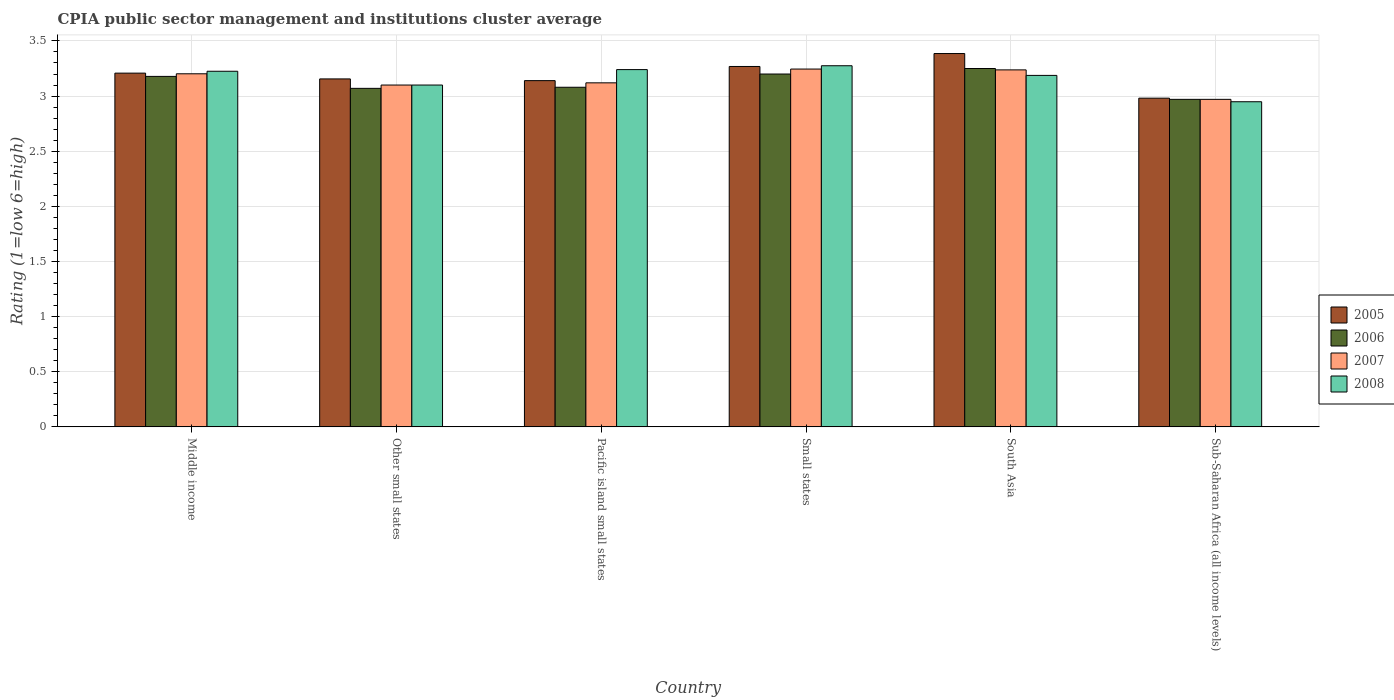Are the number of bars on each tick of the X-axis equal?
Offer a very short reply. Yes. What is the label of the 2nd group of bars from the left?
Provide a short and direct response. Other small states. What is the CPIA rating in 2008 in Other small states?
Offer a terse response. 3.1. Across all countries, what is the maximum CPIA rating in 2007?
Give a very brief answer. 3.25. Across all countries, what is the minimum CPIA rating in 2008?
Give a very brief answer. 2.95. In which country was the CPIA rating in 2008 maximum?
Offer a very short reply. Small states. In which country was the CPIA rating in 2007 minimum?
Your answer should be very brief. Sub-Saharan Africa (all income levels). What is the total CPIA rating in 2007 in the graph?
Provide a short and direct response. 18.87. What is the difference between the CPIA rating in 2008 in Other small states and that in Sub-Saharan Africa (all income levels)?
Provide a short and direct response. 0.15. What is the difference between the CPIA rating in 2007 in South Asia and the CPIA rating in 2008 in Small states?
Provide a short and direct response. -0.04. What is the average CPIA rating in 2008 per country?
Ensure brevity in your answer.  3.16. What is the difference between the CPIA rating of/in 2005 and CPIA rating of/in 2007 in Other small states?
Make the answer very short. 0.06. What is the ratio of the CPIA rating in 2008 in Middle income to that in Other small states?
Make the answer very short. 1.04. What is the difference between the highest and the second highest CPIA rating in 2007?
Offer a very short reply. -0.01. What is the difference between the highest and the lowest CPIA rating in 2005?
Your response must be concise. 0.4. In how many countries, is the CPIA rating in 2006 greater than the average CPIA rating in 2006 taken over all countries?
Give a very brief answer. 3. Is the sum of the CPIA rating in 2006 in Middle income and Pacific island small states greater than the maximum CPIA rating in 2007 across all countries?
Offer a very short reply. Yes. Is it the case that in every country, the sum of the CPIA rating in 2008 and CPIA rating in 2005 is greater than the sum of CPIA rating in 2006 and CPIA rating in 2007?
Make the answer very short. No. What does the 3rd bar from the left in South Asia represents?
Your answer should be very brief. 2007. What does the 2nd bar from the right in Middle income represents?
Your answer should be very brief. 2007. Are all the bars in the graph horizontal?
Give a very brief answer. No. How many countries are there in the graph?
Ensure brevity in your answer.  6. What is the difference between two consecutive major ticks on the Y-axis?
Offer a very short reply. 0.5. Does the graph contain any zero values?
Ensure brevity in your answer.  No. Does the graph contain grids?
Your answer should be very brief. Yes. Where does the legend appear in the graph?
Offer a very short reply. Center right. How many legend labels are there?
Your answer should be compact. 4. What is the title of the graph?
Offer a very short reply. CPIA public sector management and institutions cluster average. Does "1975" appear as one of the legend labels in the graph?
Offer a terse response. No. What is the label or title of the X-axis?
Offer a terse response. Country. What is the Rating (1=low 6=high) of 2005 in Middle income?
Give a very brief answer. 3.21. What is the Rating (1=low 6=high) in 2006 in Middle income?
Your answer should be very brief. 3.18. What is the Rating (1=low 6=high) in 2007 in Middle income?
Make the answer very short. 3.2. What is the Rating (1=low 6=high) of 2008 in Middle income?
Provide a succinct answer. 3.23. What is the Rating (1=low 6=high) of 2005 in Other small states?
Ensure brevity in your answer.  3.16. What is the Rating (1=low 6=high) of 2006 in Other small states?
Provide a succinct answer. 3.07. What is the Rating (1=low 6=high) in 2008 in Other small states?
Keep it short and to the point. 3.1. What is the Rating (1=low 6=high) of 2005 in Pacific island small states?
Make the answer very short. 3.14. What is the Rating (1=low 6=high) of 2006 in Pacific island small states?
Your response must be concise. 3.08. What is the Rating (1=low 6=high) of 2007 in Pacific island small states?
Your answer should be very brief. 3.12. What is the Rating (1=low 6=high) in 2008 in Pacific island small states?
Your response must be concise. 3.24. What is the Rating (1=low 6=high) of 2005 in Small states?
Offer a terse response. 3.27. What is the Rating (1=low 6=high) in 2007 in Small states?
Ensure brevity in your answer.  3.25. What is the Rating (1=low 6=high) of 2008 in Small states?
Your response must be concise. 3.27. What is the Rating (1=low 6=high) in 2005 in South Asia?
Keep it short and to the point. 3.39. What is the Rating (1=low 6=high) in 2006 in South Asia?
Provide a succinct answer. 3.25. What is the Rating (1=low 6=high) in 2007 in South Asia?
Your response must be concise. 3.24. What is the Rating (1=low 6=high) in 2008 in South Asia?
Provide a short and direct response. 3.19. What is the Rating (1=low 6=high) in 2005 in Sub-Saharan Africa (all income levels)?
Ensure brevity in your answer.  2.98. What is the Rating (1=low 6=high) in 2006 in Sub-Saharan Africa (all income levels)?
Ensure brevity in your answer.  2.97. What is the Rating (1=low 6=high) in 2007 in Sub-Saharan Africa (all income levels)?
Make the answer very short. 2.97. What is the Rating (1=low 6=high) in 2008 in Sub-Saharan Africa (all income levels)?
Ensure brevity in your answer.  2.95. Across all countries, what is the maximum Rating (1=low 6=high) of 2005?
Keep it short and to the point. 3.39. Across all countries, what is the maximum Rating (1=low 6=high) of 2006?
Provide a short and direct response. 3.25. Across all countries, what is the maximum Rating (1=low 6=high) in 2007?
Your answer should be very brief. 3.25. Across all countries, what is the maximum Rating (1=low 6=high) in 2008?
Provide a succinct answer. 3.27. Across all countries, what is the minimum Rating (1=low 6=high) of 2005?
Provide a succinct answer. 2.98. Across all countries, what is the minimum Rating (1=low 6=high) of 2006?
Your answer should be compact. 2.97. Across all countries, what is the minimum Rating (1=low 6=high) of 2007?
Your response must be concise. 2.97. Across all countries, what is the minimum Rating (1=low 6=high) in 2008?
Offer a very short reply. 2.95. What is the total Rating (1=low 6=high) of 2005 in the graph?
Offer a terse response. 19.14. What is the total Rating (1=low 6=high) in 2006 in the graph?
Your answer should be very brief. 18.75. What is the total Rating (1=low 6=high) in 2007 in the graph?
Make the answer very short. 18.87. What is the total Rating (1=low 6=high) in 2008 in the graph?
Your answer should be very brief. 18.98. What is the difference between the Rating (1=low 6=high) of 2005 in Middle income and that in Other small states?
Provide a short and direct response. 0.05. What is the difference between the Rating (1=low 6=high) in 2006 in Middle income and that in Other small states?
Make the answer very short. 0.11. What is the difference between the Rating (1=low 6=high) in 2007 in Middle income and that in Other small states?
Your answer should be very brief. 0.1. What is the difference between the Rating (1=low 6=high) in 2008 in Middle income and that in Other small states?
Keep it short and to the point. 0.12. What is the difference between the Rating (1=low 6=high) of 2005 in Middle income and that in Pacific island small states?
Your answer should be very brief. 0.07. What is the difference between the Rating (1=low 6=high) of 2006 in Middle income and that in Pacific island small states?
Make the answer very short. 0.1. What is the difference between the Rating (1=low 6=high) of 2007 in Middle income and that in Pacific island small states?
Provide a succinct answer. 0.08. What is the difference between the Rating (1=low 6=high) in 2008 in Middle income and that in Pacific island small states?
Give a very brief answer. -0.01. What is the difference between the Rating (1=low 6=high) in 2005 in Middle income and that in Small states?
Ensure brevity in your answer.  -0.06. What is the difference between the Rating (1=low 6=high) of 2006 in Middle income and that in Small states?
Keep it short and to the point. -0.02. What is the difference between the Rating (1=low 6=high) of 2007 in Middle income and that in Small states?
Give a very brief answer. -0.04. What is the difference between the Rating (1=low 6=high) in 2008 in Middle income and that in Small states?
Offer a very short reply. -0.05. What is the difference between the Rating (1=low 6=high) of 2005 in Middle income and that in South Asia?
Your response must be concise. -0.18. What is the difference between the Rating (1=low 6=high) of 2006 in Middle income and that in South Asia?
Your answer should be very brief. -0.07. What is the difference between the Rating (1=low 6=high) in 2007 in Middle income and that in South Asia?
Your answer should be very brief. -0.04. What is the difference between the Rating (1=low 6=high) of 2008 in Middle income and that in South Asia?
Make the answer very short. 0.04. What is the difference between the Rating (1=low 6=high) of 2005 in Middle income and that in Sub-Saharan Africa (all income levels)?
Your response must be concise. 0.23. What is the difference between the Rating (1=low 6=high) in 2006 in Middle income and that in Sub-Saharan Africa (all income levels)?
Give a very brief answer. 0.21. What is the difference between the Rating (1=low 6=high) in 2007 in Middle income and that in Sub-Saharan Africa (all income levels)?
Your response must be concise. 0.23. What is the difference between the Rating (1=low 6=high) of 2008 in Middle income and that in Sub-Saharan Africa (all income levels)?
Your answer should be compact. 0.28. What is the difference between the Rating (1=low 6=high) in 2005 in Other small states and that in Pacific island small states?
Your answer should be compact. 0.02. What is the difference between the Rating (1=low 6=high) in 2006 in Other small states and that in Pacific island small states?
Keep it short and to the point. -0.01. What is the difference between the Rating (1=low 6=high) in 2007 in Other small states and that in Pacific island small states?
Your response must be concise. -0.02. What is the difference between the Rating (1=low 6=high) of 2008 in Other small states and that in Pacific island small states?
Make the answer very short. -0.14. What is the difference between the Rating (1=low 6=high) of 2005 in Other small states and that in Small states?
Keep it short and to the point. -0.11. What is the difference between the Rating (1=low 6=high) of 2006 in Other small states and that in Small states?
Ensure brevity in your answer.  -0.13. What is the difference between the Rating (1=low 6=high) in 2007 in Other small states and that in Small states?
Provide a succinct answer. -0.14. What is the difference between the Rating (1=low 6=high) in 2008 in Other small states and that in Small states?
Provide a short and direct response. -0.17. What is the difference between the Rating (1=low 6=high) of 2005 in Other small states and that in South Asia?
Provide a succinct answer. -0.23. What is the difference between the Rating (1=low 6=high) of 2006 in Other small states and that in South Asia?
Your answer should be compact. -0.18. What is the difference between the Rating (1=low 6=high) in 2007 in Other small states and that in South Asia?
Your response must be concise. -0.14. What is the difference between the Rating (1=low 6=high) of 2008 in Other small states and that in South Asia?
Your response must be concise. -0.09. What is the difference between the Rating (1=low 6=high) of 2005 in Other small states and that in Sub-Saharan Africa (all income levels)?
Give a very brief answer. 0.17. What is the difference between the Rating (1=low 6=high) in 2006 in Other small states and that in Sub-Saharan Africa (all income levels)?
Your answer should be very brief. 0.1. What is the difference between the Rating (1=low 6=high) in 2007 in Other small states and that in Sub-Saharan Africa (all income levels)?
Make the answer very short. 0.13. What is the difference between the Rating (1=low 6=high) of 2008 in Other small states and that in Sub-Saharan Africa (all income levels)?
Offer a terse response. 0.15. What is the difference between the Rating (1=low 6=high) of 2005 in Pacific island small states and that in Small states?
Keep it short and to the point. -0.13. What is the difference between the Rating (1=low 6=high) of 2006 in Pacific island small states and that in Small states?
Ensure brevity in your answer.  -0.12. What is the difference between the Rating (1=low 6=high) in 2007 in Pacific island small states and that in Small states?
Keep it short and to the point. -0.12. What is the difference between the Rating (1=low 6=high) of 2008 in Pacific island small states and that in Small states?
Ensure brevity in your answer.  -0.04. What is the difference between the Rating (1=low 6=high) in 2005 in Pacific island small states and that in South Asia?
Provide a succinct answer. -0.25. What is the difference between the Rating (1=low 6=high) in 2006 in Pacific island small states and that in South Asia?
Give a very brief answer. -0.17. What is the difference between the Rating (1=low 6=high) of 2007 in Pacific island small states and that in South Asia?
Your answer should be compact. -0.12. What is the difference between the Rating (1=low 6=high) in 2008 in Pacific island small states and that in South Asia?
Give a very brief answer. 0.05. What is the difference between the Rating (1=low 6=high) in 2005 in Pacific island small states and that in Sub-Saharan Africa (all income levels)?
Your answer should be very brief. 0.16. What is the difference between the Rating (1=low 6=high) of 2006 in Pacific island small states and that in Sub-Saharan Africa (all income levels)?
Provide a short and direct response. 0.11. What is the difference between the Rating (1=low 6=high) of 2007 in Pacific island small states and that in Sub-Saharan Africa (all income levels)?
Your response must be concise. 0.15. What is the difference between the Rating (1=low 6=high) of 2008 in Pacific island small states and that in Sub-Saharan Africa (all income levels)?
Your response must be concise. 0.29. What is the difference between the Rating (1=low 6=high) of 2005 in Small states and that in South Asia?
Your answer should be very brief. -0.12. What is the difference between the Rating (1=low 6=high) of 2006 in Small states and that in South Asia?
Provide a short and direct response. -0.05. What is the difference between the Rating (1=low 6=high) of 2007 in Small states and that in South Asia?
Provide a succinct answer. 0.01. What is the difference between the Rating (1=low 6=high) in 2008 in Small states and that in South Asia?
Your answer should be very brief. 0.09. What is the difference between the Rating (1=low 6=high) of 2005 in Small states and that in Sub-Saharan Africa (all income levels)?
Make the answer very short. 0.29. What is the difference between the Rating (1=low 6=high) in 2006 in Small states and that in Sub-Saharan Africa (all income levels)?
Your response must be concise. 0.23. What is the difference between the Rating (1=low 6=high) in 2007 in Small states and that in Sub-Saharan Africa (all income levels)?
Your answer should be very brief. 0.27. What is the difference between the Rating (1=low 6=high) in 2008 in Small states and that in Sub-Saharan Africa (all income levels)?
Your answer should be compact. 0.33. What is the difference between the Rating (1=low 6=high) in 2005 in South Asia and that in Sub-Saharan Africa (all income levels)?
Keep it short and to the point. 0.4. What is the difference between the Rating (1=low 6=high) of 2006 in South Asia and that in Sub-Saharan Africa (all income levels)?
Your answer should be compact. 0.28. What is the difference between the Rating (1=low 6=high) in 2007 in South Asia and that in Sub-Saharan Africa (all income levels)?
Give a very brief answer. 0.27. What is the difference between the Rating (1=low 6=high) of 2008 in South Asia and that in Sub-Saharan Africa (all income levels)?
Provide a succinct answer. 0.24. What is the difference between the Rating (1=low 6=high) in 2005 in Middle income and the Rating (1=low 6=high) in 2006 in Other small states?
Provide a short and direct response. 0.14. What is the difference between the Rating (1=low 6=high) in 2005 in Middle income and the Rating (1=low 6=high) in 2007 in Other small states?
Your answer should be compact. 0.11. What is the difference between the Rating (1=low 6=high) in 2005 in Middle income and the Rating (1=low 6=high) in 2008 in Other small states?
Provide a short and direct response. 0.11. What is the difference between the Rating (1=low 6=high) in 2006 in Middle income and the Rating (1=low 6=high) in 2007 in Other small states?
Offer a very short reply. 0.08. What is the difference between the Rating (1=low 6=high) in 2006 in Middle income and the Rating (1=low 6=high) in 2008 in Other small states?
Keep it short and to the point. 0.08. What is the difference between the Rating (1=low 6=high) in 2007 in Middle income and the Rating (1=low 6=high) in 2008 in Other small states?
Make the answer very short. 0.1. What is the difference between the Rating (1=low 6=high) of 2005 in Middle income and the Rating (1=low 6=high) of 2006 in Pacific island small states?
Offer a very short reply. 0.13. What is the difference between the Rating (1=low 6=high) of 2005 in Middle income and the Rating (1=low 6=high) of 2007 in Pacific island small states?
Provide a succinct answer. 0.09. What is the difference between the Rating (1=low 6=high) in 2005 in Middle income and the Rating (1=low 6=high) in 2008 in Pacific island small states?
Your response must be concise. -0.03. What is the difference between the Rating (1=low 6=high) of 2006 in Middle income and the Rating (1=low 6=high) of 2007 in Pacific island small states?
Ensure brevity in your answer.  0.06. What is the difference between the Rating (1=low 6=high) of 2006 in Middle income and the Rating (1=low 6=high) of 2008 in Pacific island small states?
Your answer should be very brief. -0.06. What is the difference between the Rating (1=low 6=high) of 2007 in Middle income and the Rating (1=low 6=high) of 2008 in Pacific island small states?
Make the answer very short. -0.04. What is the difference between the Rating (1=low 6=high) in 2005 in Middle income and the Rating (1=low 6=high) in 2006 in Small states?
Keep it short and to the point. 0.01. What is the difference between the Rating (1=low 6=high) in 2005 in Middle income and the Rating (1=low 6=high) in 2007 in Small states?
Provide a succinct answer. -0.04. What is the difference between the Rating (1=low 6=high) of 2005 in Middle income and the Rating (1=low 6=high) of 2008 in Small states?
Your answer should be very brief. -0.07. What is the difference between the Rating (1=low 6=high) of 2006 in Middle income and the Rating (1=low 6=high) of 2007 in Small states?
Your answer should be very brief. -0.07. What is the difference between the Rating (1=low 6=high) in 2006 in Middle income and the Rating (1=low 6=high) in 2008 in Small states?
Provide a short and direct response. -0.1. What is the difference between the Rating (1=low 6=high) of 2007 in Middle income and the Rating (1=low 6=high) of 2008 in Small states?
Your response must be concise. -0.07. What is the difference between the Rating (1=low 6=high) in 2005 in Middle income and the Rating (1=low 6=high) in 2006 in South Asia?
Provide a succinct answer. -0.04. What is the difference between the Rating (1=low 6=high) of 2005 in Middle income and the Rating (1=low 6=high) of 2007 in South Asia?
Ensure brevity in your answer.  -0.03. What is the difference between the Rating (1=low 6=high) of 2005 in Middle income and the Rating (1=low 6=high) of 2008 in South Asia?
Provide a short and direct response. 0.02. What is the difference between the Rating (1=low 6=high) of 2006 in Middle income and the Rating (1=low 6=high) of 2007 in South Asia?
Provide a short and direct response. -0.06. What is the difference between the Rating (1=low 6=high) of 2006 in Middle income and the Rating (1=low 6=high) of 2008 in South Asia?
Offer a terse response. -0.01. What is the difference between the Rating (1=low 6=high) in 2007 in Middle income and the Rating (1=low 6=high) in 2008 in South Asia?
Offer a very short reply. 0.01. What is the difference between the Rating (1=low 6=high) of 2005 in Middle income and the Rating (1=low 6=high) of 2006 in Sub-Saharan Africa (all income levels)?
Provide a short and direct response. 0.24. What is the difference between the Rating (1=low 6=high) in 2005 in Middle income and the Rating (1=low 6=high) in 2007 in Sub-Saharan Africa (all income levels)?
Offer a very short reply. 0.24. What is the difference between the Rating (1=low 6=high) in 2005 in Middle income and the Rating (1=low 6=high) in 2008 in Sub-Saharan Africa (all income levels)?
Your answer should be compact. 0.26. What is the difference between the Rating (1=low 6=high) of 2006 in Middle income and the Rating (1=low 6=high) of 2007 in Sub-Saharan Africa (all income levels)?
Provide a short and direct response. 0.21. What is the difference between the Rating (1=low 6=high) in 2006 in Middle income and the Rating (1=low 6=high) in 2008 in Sub-Saharan Africa (all income levels)?
Your answer should be compact. 0.23. What is the difference between the Rating (1=low 6=high) of 2007 in Middle income and the Rating (1=low 6=high) of 2008 in Sub-Saharan Africa (all income levels)?
Provide a short and direct response. 0.25. What is the difference between the Rating (1=low 6=high) of 2005 in Other small states and the Rating (1=low 6=high) of 2006 in Pacific island small states?
Keep it short and to the point. 0.08. What is the difference between the Rating (1=low 6=high) in 2005 in Other small states and the Rating (1=low 6=high) in 2007 in Pacific island small states?
Keep it short and to the point. 0.04. What is the difference between the Rating (1=low 6=high) of 2005 in Other small states and the Rating (1=low 6=high) of 2008 in Pacific island small states?
Ensure brevity in your answer.  -0.08. What is the difference between the Rating (1=low 6=high) in 2006 in Other small states and the Rating (1=low 6=high) in 2007 in Pacific island small states?
Your response must be concise. -0.05. What is the difference between the Rating (1=low 6=high) of 2006 in Other small states and the Rating (1=low 6=high) of 2008 in Pacific island small states?
Your response must be concise. -0.17. What is the difference between the Rating (1=low 6=high) in 2007 in Other small states and the Rating (1=low 6=high) in 2008 in Pacific island small states?
Offer a terse response. -0.14. What is the difference between the Rating (1=low 6=high) of 2005 in Other small states and the Rating (1=low 6=high) of 2006 in Small states?
Give a very brief answer. -0.04. What is the difference between the Rating (1=low 6=high) of 2005 in Other small states and the Rating (1=low 6=high) of 2007 in Small states?
Ensure brevity in your answer.  -0.09. What is the difference between the Rating (1=low 6=high) of 2005 in Other small states and the Rating (1=low 6=high) of 2008 in Small states?
Keep it short and to the point. -0.12. What is the difference between the Rating (1=low 6=high) of 2006 in Other small states and the Rating (1=low 6=high) of 2007 in Small states?
Ensure brevity in your answer.  -0.17. What is the difference between the Rating (1=low 6=high) of 2006 in Other small states and the Rating (1=low 6=high) of 2008 in Small states?
Provide a succinct answer. -0.2. What is the difference between the Rating (1=low 6=high) of 2007 in Other small states and the Rating (1=low 6=high) of 2008 in Small states?
Keep it short and to the point. -0.17. What is the difference between the Rating (1=low 6=high) of 2005 in Other small states and the Rating (1=low 6=high) of 2006 in South Asia?
Make the answer very short. -0.09. What is the difference between the Rating (1=low 6=high) of 2005 in Other small states and the Rating (1=low 6=high) of 2007 in South Asia?
Your answer should be compact. -0.08. What is the difference between the Rating (1=low 6=high) in 2005 in Other small states and the Rating (1=low 6=high) in 2008 in South Asia?
Keep it short and to the point. -0.03. What is the difference between the Rating (1=low 6=high) of 2006 in Other small states and the Rating (1=low 6=high) of 2007 in South Asia?
Your answer should be very brief. -0.17. What is the difference between the Rating (1=low 6=high) of 2006 in Other small states and the Rating (1=low 6=high) of 2008 in South Asia?
Make the answer very short. -0.12. What is the difference between the Rating (1=low 6=high) in 2007 in Other small states and the Rating (1=low 6=high) in 2008 in South Asia?
Your response must be concise. -0.09. What is the difference between the Rating (1=low 6=high) of 2005 in Other small states and the Rating (1=low 6=high) of 2006 in Sub-Saharan Africa (all income levels)?
Offer a very short reply. 0.19. What is the difference between the Rating (1=low 6=high) of 2005 in Other small states and the Rating (1=low 6=high) of 2007 in Sub-Saharan Africa (all income levels)?
Offer a very short reply. 0.19. What is the difference between the Rating (1=low 6=high) of 2005 in Other small states and the Rating (1=low 6=high) of 2008 in Sub-Saharan Africa (all income levels)?
Give a very brief answer. 0.21. What is the difference between the Rating (1=low 6=high) in 2006 in Other small states and the Rating (1=low 6=high) in 2007 in Sub-Saharan Africa (all income levels)?
Make the answer very short. 0.1. What is the difference between the Rating (1=low 6=high) in 2006 in Other small states and the Rating (1=low 6=high) in 2008 in Sub-Saharan Africa (all income levels)?
Make the answer very short. 0.12. What is the difference between the Rating (1=low 6=high) in 2007 in Other small states and the Rating (1=low 6=high) in 2008 in Sub-Saharan Africa (all income levels)?
Your answer should be compact. 0.15. What is the difference between the Rating (1=low 6=high) in 2005 in Pacific island small states and the Rating (1=low 6=high) in 2006 in Small states?
Ensure brevity in your answer.  -0.06. What is the difference between the Rating (1=low 6=high) in 2005 in Pacific island small states and the Rating (1=low 6=high) in 2007 in Small states?
Give a very brief answer. -0.1. What is the difference between the Rating (1=low 6=high) of 2005 in Pacific island small states and the Rating (1=low 6=high) of 2008 in Small states?
Provide a succinct answer. -0.14. What is the difference between the Rating (1=low 6=high) in 2006 in Pacific island small states and the Rating (1=low 6=high) in 2007 in Small states?
Provide a succinct answer. -0.17. What is the difference between the Rating (1=low 6=high) of 2006 in Pacific island small states and the Rating (1=low 6=high) of 2008 in Small states?
Offer a very short reply. -0.2. What is the difference between the Rating (1=low 6=high) in 2007 in Pacific island small states and the Rating (1=low 6=high) in 2008 in Small states?
Your answer should be very brief. -0.15. What is the difference between the Rating (1=low 6=high) of 2005 in Pacific island small states and the Rating (1=low 6=high) of 2006 in South Asia?
Provide a short and direct response. -0.11. What is the difference between the Rating (1=low 6=high) in 2005 in Pacific island small states and the Rating (1=low 6=high) in 2007 in South Asia?
Your answer should be compact. -0.1. What is the difference between the Rating (1=low 6=high) in 2005 in Pacific island small states and the Rating (1=low 6=high) in 2008 in South Asia?
Ensure brevity in your answer.  -0.05. What is the difference between the Rating (1=low 6=high) in 2006 in Pacific island small states and the Rating (1=low 6=high) in 2007 in South Asia?
Provide a succinct answer. -0.16. What is the difference between the Rating (1=low 6=high) in 2006 in Pacific island small states and the Rating (1=low 6=high) in 2008 in South Asia?
Ensure brevity in your answer.  -0.11. What is the difference between the Rating (1=low 6=high) of 2007 in Pacific island small states and the Rating (1=low 6=high) of 2008 in South Asia?
Your response must be concise. -0.07. What is the difference between the Rating (1=low 6=high) in 2005 in Pacific island small states and the Rating (1=low 6=high) in 2006 in Sub-Saharan Africa (all income levels)?
Give a very brief answer. 0.17. What is the difference between the Rating (1=low 6=high) of 2005 in Pacific island small states and the Rating (1=low 6=high) of 2007 in Sub-Saharan Africa (all income levels)?
Keep it short and to the point. 0.17. What is the difference between the Rating (1=low 6=high) in 2005 in Pacific island small states and the Rating (1=low 6=high) in 2008 in Sub-Saharan Africa (all income levels)?
Keep it short and to the point. 0.19. What is the difference between the Rating (1=low 6=high) of 2006 in Pacific island small states and the Rating (1=low 6=high) of 2007 in Sub-Saharan Africa (all income levels)?
Provide a short and direct response. 0.11. What is the difference between the Rating (1=low 6=high) of 2006 in Pacific island small states and the Rating (1=low 6=high) of 2008 in Sub-Saharan Africa (all income levels)?
Provide a short and direct response. 0.13. What is the difference between the Rating (1=low 6=high) of 2007 in Pacific island small states and the Rating (1=low 6=high) of 2008 in Sub-Saharan Africa (all income levels)?
Make the answer very short. 0.17. What is the difference between the Rating (1=low 6=high) of 2005 in Small states and the Rating (1=low 6=high) of 2006 in South Asia?
Keep it short and to the point. 0.02. What is the difference between the Rating (1=low 6=high) of 2005 in Small states and the Rating (1=low 6=high) of 2007 in South Asia?
Your answer should be very brief. 0.03. What is the difference between the Rating (1=low 6=high) of 2005 in Small states and the Rating (1=low 6=high) of 2008 in South Asia?
Your response must be concise. 0.08. What is the difference between the Rating (1=low 6=high) of 2006 in Small states and the Rating (1=low 6=high) of 2007 in South Asia?
Ensure brevity in your answer.  -0.04. What is the difference between the Rating (1=low 6=high) of 2006 in Small states and the Rating (1=low 6=high) of 2008 in South Asia?
Offer a very short reply. 0.01. What is the difference between the Rating (1=low 6=high) in 2007 in Small states and the Rating (1=low 6=high) in 2008 in South Asia?
Offer a very short reply. 0.06. What is the difference between the Rating (1=low 6=high) of 2005 in Small states and the Rating (1=low 6=high) of 2006 in Sub-Saharan Africa (all income levels)?
Provide a succinct answer. 0.3. What is the difference between the Rating (1=low 6=high) in 2005 in Small states and the Rating (1=low 6=high) in 2007 in Sub-Saharan Africa (all income levels)?
Your answer should be very brief. 0.3. What is the difference between the Rating (1=low 6=high) in 2005 in Small states and the Rating (1=low 6=high) in 2008 in Sub-Saharan Africa (all income levels)?
Keep it short and to the point. 0.32. What is the difference between the Rating (1=low 6=high) in 2006 in Small states and the Rating (1=low 6=high) in 2007 in Sub-Saharan Africa (all income levels)?
Offer a terse response. 0.23. What is the difference between the Rating (1=low 6=high) of 2006 in Small states and the Rating (1=low 6=high) of 2008 in Sub-Saharan Africa (all income levels)?
Make the answer very short. 0.25. What is the difference between the Rating (1=low 6=high) in 2007 in Small states and the Rating (1=low 6=high) in 2008 in Sub-Saharan Africa (all income levels)?
Provide a short and direct response. 0.3. What is the difference between the Rating (1=low 6=high) of 2005 in South Asia and the Rating (1=low 6=high) of 2006 in Sub-Saharan Africa (all income levels)?
Keep it short and to the point. 0.42. What is the difference between the Rating (1=low 6=high) in 2005 in South Asia and the Rating (1=low 6=high) in 2007 in Sub-Saharan Africa (all income levels)?
Offer a terse response. 0.42. What is the difference between the Rating (1=low 6=high) in 2005 in South Asia and the Rating (1=low 6=high) in 2008 in Sub-Saharan Africa (all income levels)?
Ensure brevity in your answer.  0.44. What is the difference between the Rating (1=low 6=high) of 2006 in South Asia and the Rating (1=low 6=high) of 2007 in Sub-Saharan Africa (all income levels)?
Give a very brief answer. 0.28. What is the difference between the Rating (1=low 6=high) in 2006 in South Asia and the Rating (1=low 6=high) in 2008 in Sub-Saharan Africa (all income levels)?
Offer a terse response. 0.3. What is the difference between the Rating (1=low 6=high) in 2007 in South Asia and the Rating (1=low 6=high) in 2008 in Sub-Saharan Africa (all income levels)?
Give a very brief answer. 0.29. What is the average Rating (1=low 6=high) in 2005 per country?
Provide a succinct answer. 3.19. What is the average Rating (1=low 6=high) of 2006 per country?
Provide a succinct answer. 3.12. What is the average Rating (1=low 6=high) of 2007 per country?
Provide a short and direct response. 3.15. What is the average Rating (1=low 6=high) in 2008 per country?
Your answer should be compact. 3.16. What is the difference between the Rating (1=low 6=high) in 2005 and Rating (1=low 6=high) in 2006 in Middle income?
Make the answer very short. 0.03. What is the difference between the Rating (1=low 6=high) of 2005 and Rating (1=low 6=high) of 2007 in Middle income?
Provide a short and direct response. 0.01. What is the difference between the Rating (1=low 6=high) in 2005 and Rating (1=low 6=high) in 2008 in Middle income?
Offer a terse response. -0.02. What is the difference between the Rating (1=low 6=high) of 2006 and Rating (1=low 6=high) of 2007 in Middle income?
Offer a terse response. -0.02. What is the difference between the Rating (1=low 6=high) in 2006 and Rating (1=low 6=high) in 2008 in Middle income?
Provide a short and direct response. -0.05. What is the difference between the Rating (1=low 6=high) in 2007 and Rating (1=low 6=high) in 2008 in Middle income?
Offer a terse response. -0.02. What is the difference between the Rating (1=low 6=high) of 2005 and Rating (1=low 6=high) of 2006 in Other small states?
Ensure brevity in your answer.  0.09. What is the difference between the Rating (1=low 6=high) in 2005 and Rating (1=low 6=high) in 2007 in Other small states?
Offer a very short reply. 0.06. What is the difference between the Rating (1=low 6=high) in 2005 and Rating (1=low 6=high) in 2008 in Other small states?
Your answer should be compact. 0.06. What is the difference between the Rating (1=low 6=high) of 2006 and Rating (1=low 6=high) of 2007 in Other small states?
Give a very brief answer. -0.03. What is the difference between the Rating (1=low 6=high) of 2006 and Rating (1=low 6=high) of 2008 in Other small states?
Provide a succinct answer. -0.03. What is the difference between the Rating (1=low 6=high) in 2007 and Rating (1=low 6=high) in 2008 in Other small states?
Provide a short and direct response. 0. What is the difference between the Rating (1=low 6=high) in 2005 and Rating (1=low 6=high) in 2007 in Pacific island small states?
Provide a succinct answer. 0.02. What is the difference between the Rating (1=low 6=high) of 2006 and Rating (1=low 6=high) of 2007 in Pacific island small states?
Ensure brevity in your answer.  -0.04. What is the difference between the Rating (1=low 6=high) in 2006 and Rating (1=low 6=high) in 2008 in Pacific island small states?
Your response must be concise. -0.16. What is the difference between the Rating (1=low 6=high) of 2007 and Rating (1=low 6=high) of 2008 in Pacific island small states?
Ensure brevity in your answer.  -0.12. What is the difference between the Rating (1=low 6=high) of 2005 and Rating (1=low 6=high) of 2006 in Small states?
Ensure brevity in your answer.  0.07. What is the difference between the Rating (1=low 6=high) of 2005 and Rating (1=low 6=high) of 2007 in Small states?
Keep it short and to the point. 0.02. What is the difference between the Rating (1=low 6=high) of 2005 and Rating (1=low 6=high) of 2008 in Small states?
Provide a short and direct response. -0.01. What is the difference between the Rating (1=low 6=high) of 2006 and Rating (1=low 6=high) of 2007 in Small states?
Offer a very short reply. -0.04. What is the difference between the Rating (1=low 6=high) of 2006 and Rating (1=low 6=high) of 2008 in Small states?
Provide a succinct answer. -0.07. What is the difference between the Rating (1=low 6=high) of 2007 and Rating (1=low 6=high) of 2008 in Small states?
Your answer should be very brief. -0.03. What is the difference between the Rating (1=low 6=high) in 2005 and Rating (1=low 6=high) in 2006 in South Asia?
Provide a succinct answer. 0.14. What is the difference between the Rating (1=low 6=high) of 2005 and Rating (1=low 6=high) of 2007 in South Asia?
Your answer should be very brief. 0.15. What is the difference between the Rating (1=low 6=high) in 2005 and Rating (1=low 6=high) in 2008 in South Asia?
Your answer should be very brief. 0.2. What is the difference between the Rating (1=low 6=high) in 2006 and Rating (1=low 6=high) in 2007 in South Asia?
Keep it short and to the point. 0.01. What is the difference between the Rating (1=low 6=high) of 2006 and Rating (1=low 6=high) of 2008 in South Asia?
Your response must be concise. 0.06. What is the difference between the Rating (1=low 6=high) in 2005 and Rating (1=low 6=high) in 2006 in Sub-Saharan Africa (all income levels)?
Your response must be concise. 0.01. What is the difference between the Rating (1=low 6=high) in 2005 and Rating (1=low 6=high) in 2007 in Sub-Saharan Africa (all income levels)?
Offer a terse response. 0.01. What is the difference between the Rating (1=low 6=high) in 2005 and Rating (1=low 6=high) in 2008 in Sub-Saharan Africa (all income levels)?
Your response must be concise. 0.03. What is the difference between the Rating (1=low 6=high) of 2006 and Rating (1=low 6=high) of 2007 in Sub-Saharan Africa (all income levels)?
Provide a succinct answer. 0. What is the difference between the Rating (1=low 6=high) in 2006 and Rating (1=low 6=high) in 2008 in Sub-Saharan Africa (all income levels)?
Offer a terse response. 0.02. What is the difference between the Rating (1=low 6=high) in 2007 and Rating (1=low 6=high) in 2008 in Sub-Saharan Africa (all income levels)?
Offer a very short reply. 0.02. What is the ratio of the Rating (1=low 6=high) in 2005 in Middle income to that in Other small states?
Your answer should be very brief. 1.02. What is the ratio of the Rating (1=low 6=high) in 2006 in Middle income to that in Other small states?
Ensure brevity in your answer.  1.04. What is the ratio of the Rating (1=low 6=high) of 2007 in Middle income to that in Other small states?
Your answer should be compact. 1.03. What is the ratio of the Rating (1=low 6=high) of 2008 in Middle income to that in Other small states?
Your answer should be compact. 1.04. What is the ratio of the Rating (1=low 6=high) in 2005 in Middle income to that in Pacific island small states?
Offer a very short reply. 1.02. What is the ratio of the Rating (1=low 6=high) in 2006 in Middle income to that in Pacific island small states?
Make the answer very short. 1.03. What is the ratio of the Rating (1=low 6=high) of 2007 in Middle income to that in Pacific island small states?
Provide a short and direct response. 1.03. What is the ratio of the Rating (1=low 6=high) in 2005 in Middle income to that in Small states?
Offer a terse response. 0.98. What is the ratio of the Rating (1=low 6=high) of 2006 in Middle income to that in Small states?
Keep it short and to the point. 0.99. What is the ratio of the Rating (1=low 6=high) of 2007 in Middle income to that in Small states?
Provide a short and direct response. 0.99. What is the ratio of the Rating (1=low 6=high) of 2008 in Middle income to that in Small states?
Give a very brief answer. 0.98. What is the ratio of the Rating (1=low 6=high) in 2005 in Middle income to that in South Asia?
Your answer should be very brief. 0.95. What is the ratio of the Rating (1=low 6=high) in 2006 in Middle income to that in South Asia?
Offer a very short reply. 0.98. What is the ratio of the Rating (1=low 6=high) of 2007 in Middle income to that in South Asia?
Your answer should be compact. 0.99. What is the ratio of the Rating (1=low 6=high) of 2008 in Middle income to that in South Asia?
Offer a terse response. 1.01. What is the ratio of the Rating (1=low 6=high) in 2005 in Middle income to that in Sub-Saharan Africa (all income levels)?
Give a very brief answer. 1.08. What is the ratio of the Rating (1=low 6=high) in 2006 in Middle income to that in Sub-Saharan Africa (all income levels)?
Keep it short and to the point. 1.07. What is the ratio of the Rating (1=low 6=high) of 2007 in Middle income to that in Sub-Saharan Africa (all income levels)?
Your answer should be very brief. 1.08. What is the ratio of the Rating (1=low 6=high) of 2008 in Middle income to that in Sub-Saharan Africa (all income levels)?
Make the answer very short. 1.09. What is the ratio of the Rating (1=low 6=high) in 2005 in Other small states to that in Pacific island small states?
Offer a terse response. 1. What is the ratio of the Rating (1=low 6=high) in 2006 in Other small states to that in Pacific island small states?
Give a very brief answer. 1. What is the ratio of the Rating (1=low 6=high) of 2008 in Other small states to that in Pacific island small states?
Offer a terse response. 0.96. What is the ratio of the Rating (1=low 6=high) in 2005 in Other small states to that in Small states?
Your answer should be compact. 0.97. What is the ratio of the Rating (1=low 6=high) in 2006 in Other small states to that in Small states?
Keep it short and to the point. 0.96. What is the ratio of the Rating (1=low 6=high) in 2007 in Other small states to that in Small states?
Ensure brevity in your answer.  0.96. What is the ratio of the Rating (1=low 6=high) of 2008 in Other small states to that in Small states?
Keep it short and to the point. 0.95. What is the ratio of the Rating (1=low 6=high) in 2005 in Other small states to that in South Asia?
Provide a succinct answer. 0.93. What is the ratio of the Rating (1=low 6=high) of 2006 in Other small states to that in South Asia?
Your response must be concise. 0.94. What is the ratio of the Rating (1=low 6=high) of 2007 in Other small states to that in South Asia?
Your response must be concise. 0.96. What is the ratio of the Rating (1=low 6=high) in 2008 in Other small states to that in South Asia?
Your answer should be very brief. 0.97. What is the ratio of the Rating (1=low 6=high) in 2005 in Other small states to that in Sub-Saharan Africa (all income levels)?
Provide a short and direct response. 1.06. What is the ratio of the Rating (1=low 6=high) of 2006 in Other small states to that in Sub-Saharan Africa (all income levels)?
Your answer should be very brief. 1.03. What is the ratio of the Rating (1=low 6=high) in 2007 in Other small states to that in Sub-Saharan Africa (all income levels)?
Offer a very short reply. 1.04. What is the ratio of the Rating (1=low 6=high) in 2008 in Other small states to that in Sub-Saharan Africa (all income levels)?
Keep it short and to the point. 1.05. What is the ratio of the Rating (1=low 6=high) in 2005 in Pacific island small states to that in Small states?
Your answer should be very brief. 0.96. What is the ratio of the Rating (1=low 6=high) of 2006 in Pacific island small states to that in Small states?
Make the answer very short. 0.96. What is the ratio of the Rating (1=low 6=high) in 2007 in Pacific island small states to that in Small states?
Offer a very short reply. 0.96. What is the ratio of the Rating (1=low 6=high) of 2008 in Pacific island small states to that in Small states?
Ensure brevity in your answer.  0.99. What is the ratio of the Rating (1=low 6=high) in 2005 in Pacific island small states to that in South Asia?
Provide a succinct answer. 0.93. What is the ratio of the Rating (1=low 6=high) in 2006 in Pacific island small states to that in South Asia?
Give a very brief answer. 0.95. What is the ratio of the Rating (1=low 6=high) in 2007 in Pacific island small states to that in South Asia?
Your answer should be compact. 0.96. What is the ratio of the Rating (1=low 6=high) in 2008 in Pacific island small states to that in South Asia?
Your response must be concise. 1.02. What is the ratio of the Rating (1=low 6=high) in 2005 in Pacific island small states to that in Sub-Saharan Africa (all income levels)?
Ensure brevity in your answer.  1.05. What is the ratio of the Rating (1=low 6=high) in 2006 in Pacific island small states to that in Sub-Saharan Africa (all income levels)?
Ensure brevity in your answer.  1.04. What is the ratio of the Rating (1=low 6=high) in 2007 in Pacific island small states to that in Sub-Saharan Africa (all income levels)?
Your answer should be very brief. 1.05. What is the ratio of the Rating (1=low 6=high) of 2008 in Pacific island small states to that in Sub-Saharan Africa (all income levels)?
Provide a succinct answer. 1.1. What is the ratio of the Rating (1=low 6=high) of 2005 in Small states to that in South Asia?
Your answer should be very brief. 0.97. What is the ratio of the Rating (1=low 6=high) of 2006 in Small states to that in South Asia?
Offer a very short reply. 0.98. What is the ratio of the Rating (1=low 6=high) in 2007 in Small states to that in South Asia?
Keep it short and to the point. 1. What is the ratio of the Rating (1=low 6=high) of 2008 in Small states to that in South Asia?
Give a very brief answer. 1.03. What is the ratio of the Rating (1=low 6=high) of 2005 in Small states to that in Sub-Saharan Africa (all income levels)?
Ensure brevity in your answer.  1.1. What is the ratio of the Rating (1=low 6=high) in 2006 in Small states to that in Sub-Saharan Africa (all income levels)?
Your answer should be very brief. 1.08. What is the ratio of the Rating (1=low 6=high) in 2007 in Small states to that in Sub-Saharan Africa (all income levels)?
Your answer should be compact. 1.09. What is the ratio of the Rating (1=low 6=high) in 2008 in Small states to that in Sub-Saharan Africa (all income levels)?
Offer a terse response. 1.11. What is the ratio of the Rating (1=low 6=high) of 2005 in South Asia to that in Sub-Saharan Africa (all income levels)?
Provide a succinct answer. 1.14. What is the ratio of the Rating (1=low 6=high) in 2006 in South Asia to that in Sub-Saharan Africa (all income levels)?
Offer a very short reply. 1.09. What is the ratio of the Rating (1=low 6=high) of 2007 in South Asia to that in Sub-Saharan Africa (all income levels)?
Your answer should be very brief. 1.09. What is the ratio of the Rating (1=low 6=high) in 2008 in South Asia to that in Sub-Saharan Africa (all income levels)?
Offer a terse response. 1.08. What is the difference between the highest and the second highest Rating (1=low 6=high) of 2005?
Ensure brevity in your answer.  0.12. What is the difference between the highest and the second highest Rating (1=low 6=high) of 2007?
Your response must be concise. 0.01. What is the difference between the highest and the second highest Rating (1=low 6=high) of 2008?
Provide a short and direct response. 0.04. What is the difference between the highest and the lowest Rating (1=low 6=high) of 2005?
Your answer should be very brief. 0.4. What is the difference between the highest and the lowest Rating (1=low 6=high) in 2006?
Provide a short and direct response. 0.28. What is the difference between the highest and the lowest Rating (1=low 6=high) in 2007?
Keep it short and to the point. 0.27. What is the difference between the highest and the lowest Rating (1=low 6=high) in 2008?
Make the answer very short. 0.33. 